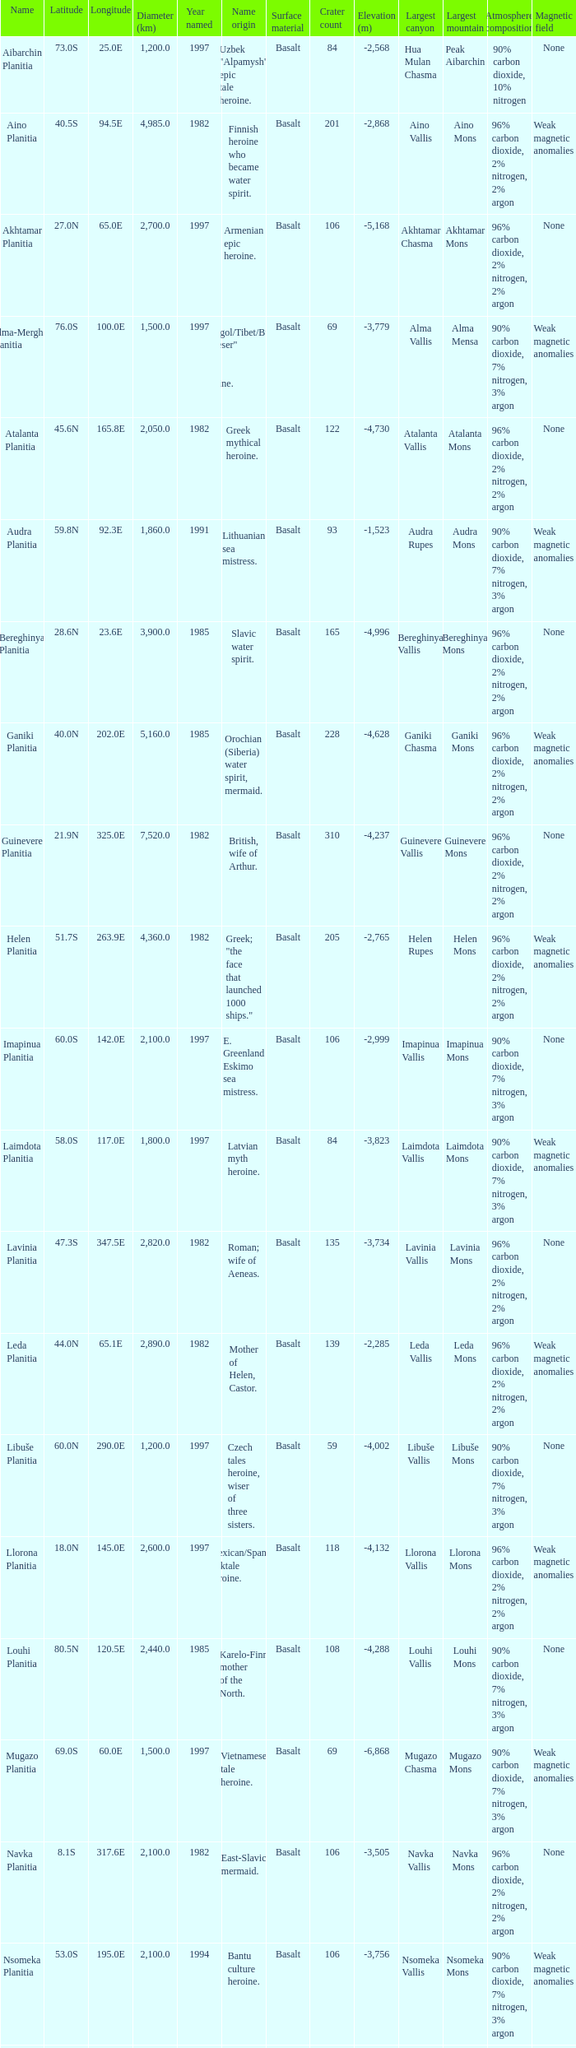What's the name origin of feature of diameter (km) 2,155.0 Karelo-Finn mermaid. 